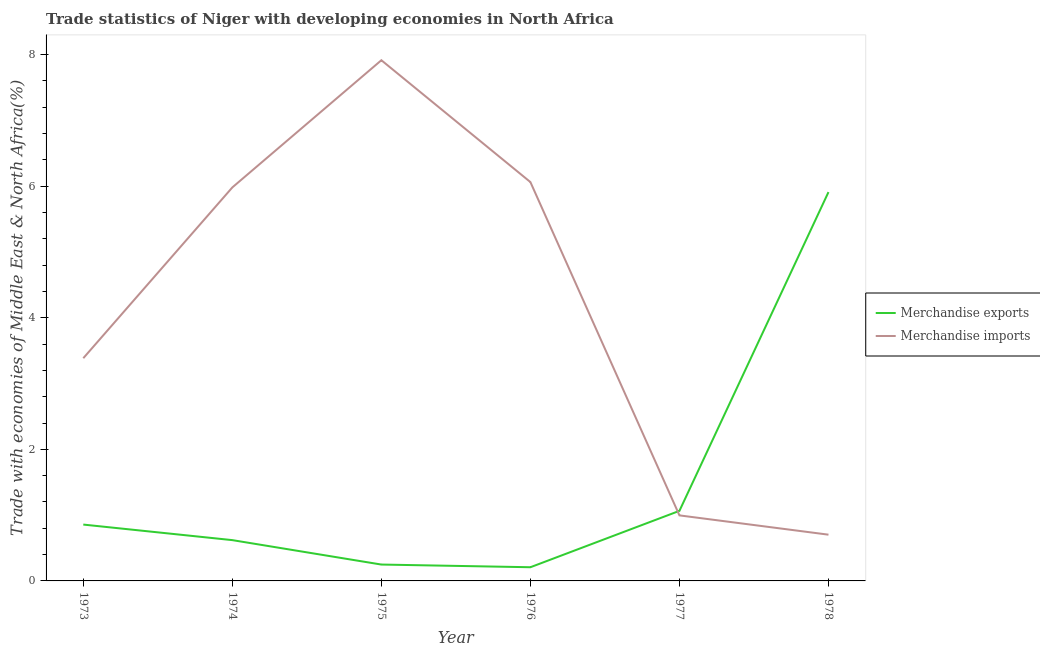Does the line corresponding to merchandise imports intersect with the line corresponding to merchandise exports?
Give a very brief answer. Yes. Is the number of lines equal to the number of legend labels?
Ensure brevity in your answer.  Yes. What is the merchandise imports in 1973?
Make the answer very short. 3.39. Across all years, what is the maximum merchandise exports?
Make the answer very short. 5.91. Across all years, what is the minimum merchandise imports?
Make the answer very short. 0.7. In which year was the merchandise exports maximum?
Provide a short and direct response. 1978. In which year was the merchandise imports minimum?
Give a very brief answer. 1978. What is the total merchandise exports in the graph?
Give a very brief answer. 8.91. What is the difference between the merchandise exports in 1977 and that in 1978?
Make the answer very short. -4.84. What is the difference between the merchandise exports in 1977 and the merchandise imports in 1978?
Give a very brief answer. 0.36. What is the average merchandise imports per year?
Your answer should be very brief. 4.17. In the year 1974, what is the difference between the merchandise imports and merchandise exports?
Offer a very short reply. 5.36. In how many years, is the merchandise exports greater than 1.6 %?
Your answer should be very brief. 1. What is the ratio of the merchandise exports in 1973 to that in 1977?
Offer a very short reply. 0.8. What is the difference between the highest and the second highest merchandise imports?
Give a very brief answer. 1.85. What is the difference between the highest and the lowest merchandise exports?
Your answer should be very brief. 5.7. Is the sum of the merchandise exports in 1974 and 1978 greater than the maximum merchandise imports across all years?
Provide a succinct answer. No. Does the merchandise exports monotonically increase over the years?
Keep it short and to the point. No. How many lines are there?
Your answer should be very brief. 2. How many years are there in the graph?
Your answer should be very brief. 6. Does the graph contain any zero values?
Offer a terse response. No. How are the legend labels stacked?
Give a very brief answer. Vertical. What is the title of the graph?
Your answer should be compact. Trade statistics of Niger with developing economies in North Africa. Does "Automatic Teller Machines" appear as one of the legend labels in the graph?
Provide a short and direct response. No. What is the label or title of the X-axis?
Offer a terse response. Year. What is the label or title of the Y-axis?
Your answer should be compact. Trade with economies of Middle East & North Africa(%). What is the Trade with economies of Middle East & North Africa(%) of Merchandise exports in 1973?
Provide a short and direct response. 0.86. What is the Trade with economies of Middle East & North Africa(%) of Merchandise imports in 1973?
Keep it short and to the point. 3.39. What is the Trade with economies of Middle East & North Africa(%) of Merchandise exports in 1974?
Make the answer very short. 0.62. What is the Trade with economies of Middle East & North Africa(%) of Merchandise imports in 1974?
Your answer should be compact. 5.98. What is the Trade with economies of Middle East & North Africa(%) in Merchandise exports in 1975?
Make the answer very short. 0.25. What is the Trade with economies of Middle East & North Africa(%) in Merchandise imports in 1975?
Make the answer very short. 7.91. What is the Trade with economies of Middle East & North Africa(%) of Merchandise exports in 1976?
Keep it short and to the point. 0.21. What is the Trade with economies of Middle East & North Africa(%) of Merchandise imports in 1976?
Offer a very short reply. 6.06. What is the Trade with economies of Middle East & North Africa(%) of Merchandise exports in 1977?
Offer a very short reply. 1.07. What is the Trade with economies of Middle East & North Africa(%) of Merchandise imports in 1977?
Make the answer very short. 1. What is the Trade with economies of Middle East & North Africa(%) in Merchandise exports in 1978?
Offer a terse response. 5.91. What is the Trade with economies of Middle East & North Africa(%) of Merchandise imports in 1978?
Your answer should be compact. 0.7. Across all years, what is the maximum Trade with economies of Middle East & North Africa(%) of Merchandise exports?
Keep it short and to the point. 5.91. Across all years, what is the maximum Trade with economies of Middle East & North Africa(%) of Merchandise imports?
Your answer should be compact. 7.91. Across all years, what is the minimum Trade with economies of Middle East & North Africa(%) of Merchandise exports?
Offer a terse response. 0.21. Across all years, what is the minimum Trade with economies of Middle East & North Africa(%) of Merchandise imports?
Give a very brief answer. 0.7. What is the total Trade with economies of Middle East & North Africa(%) of Merchandise exports in the graph?
Give a very brief answer. 8.91. What is the total Trade with economies of Middle East & North Africa(%) in Merchandise imports in the graph?
Give a very brief answer. 25.04. What is the difference between the Trade with economies of Middle East & North Africa(%) of Merchandise exports in 1973 and that in 1974?
Your response must be concise. 0.24. What is the difference between the Trade with economies of Middle East & North Africa(%) of Merchandise imports in 1973 and that in 1974?
Make the answer very short. -2.6. What is the difference between the Trade with economies of Middle East & North Africa(%) in Merchandise exports in 1973 and that in 1975?
Provide a short and direct response. 0.61. What is the difference between the Trade with economies of Middle East & North Africa(%) of Merchandise imports in 1973 and that in 1975?
Offer a terse response. -4.53. What is the difference between the Trade with economies of Middle East & North Africa(%) in Merchandise exports in 1973 and that in 1976?
Your response must be concise. 0.65. What is the difference between the Trade with economies of Middle East & North Africa(%) in Merchandise imports in 1973 and that in 1976?
Your response must be concise. -2.68. What is the difference between the Trade with economies of Middle East & North Africa(%) of Merchandise exports in 1973 and that in 1977?
Provide a short and direct response. -0.21. What is the difference between the Trade with economies of Middle East & North Africa(%) in Merchandise imports in 1973 and that in 1977?
Provide a short and direct response. 2.39. What is the difference between the Trade with economies of Middle East & North Africa(%) in Merchandise exports in 1973 and that in 1978?
Your answer should be very brief. -5.05. What is the difference between the Trade with economies of Middle East & North Africa(%) in Merchandise imports in 1973 and that in 1978?
Make the answer very short. 2.68. What is the difference between the Trade with economies of Middle East & North Africa(%) in Merchandise exports in 1974 and that in 1975?
Offer a very short reply. 0.37. What is the difference between the Trade with economies of Middle East & North Africa(%) of Merchandise imports in 1974 and that in 1975?
Offer a very short reply. -1.93. What is the difference between the Trade with economies of Middle East & North Africa(%) of Merchandise exports in 1974 and that in 1976?
Your answer should be very brief. 0.41. What is the difference between the Trade with economies of Middle East & North Africa(%) of Merchandise imports in 1974 and that in 1976?
Ensure brevity in your answer.  -0.08. What is the difference between the Trade with economies of Middle East & North Africa(%) in Merchandise exports in 1974 and that in 1977?
Offer a terse response. -0.44. What is the difference between the Trade with economies of Middle East & North Africa(%) in Merchandise imports in 1974 and that in 1977?
Your answer should be compact. 4.98. What is the difference between the Trade with economies of Middle East & North Africa(%) of Merchandise exports in 1974 and that in 1978?
Your answer should be compact. -5.29. What is the difference between the Trade with economies of Middle East & North Africa(%) in Merchandise imports in 1974 and that in 1978?
Keep it short and to the point. 5.28. What is the difference between the Trade with economies of Middle East & North Africa(%) in Merchandise exports in 1975 and that in 1976?
Offer a very short reply. 0.04. What is the difference between the Trade with economies of Middle East & North Africa(%) of Merchandise imports in 1975 and that in 1976?
Your response must be concise. 1.85. What is the difference between the Trade with economies of Middle East & North Africa(%) in Merchandise exports in 1975 and that in 1977?
Offer a very short reply. -0.82. What is the difference between the Trade with economies of Middle East & North Africa(%) of Merchandise imports in 1975 and that in 1977?
Your answer should be very brief. 6.92. What is the difference between the Trade with economies of Middle East & North Africa(%) of Merchandise exports in 1975 and that in 1978?
Provide a short and direct response. -5.66. What is the difference between the Trade with economies of Middle East & North Africa(%) in Merchandise imports in 1975 and that in 1978?
Give a very brief answer. 7.21. What is the difference between the Trade with economies of Middle East & North Africa(%) of Merchandise exports in 1976 and that in 1977?
Ensure brevity in your answer.  -0.86. What is the difference between the Trade with economies of Middle East & North Africa(%) of Merchandise imports in 1976 and that in 1977?
Ensure brevity in your answer.  5.07. What is the difference between the Trade with economies of Middle East & North Africa(%) in Merchandise exports in 1976 and that in 1978?
Offer a very short reply. -5.7. What is the difference between the Trade with economies of Middle East & North Africa(%) in Merchandise imports in 1976 and that in 1978?
Make the answer very short. 5.36. What is the difference between the Trade with economies of Middle East & North Africa(%) in Merchandise exports in 1977 and that in 1978?
Give a very brief answer. -4.84. What is the difference between the Trade with economies of Middle East & North Africa(%) of Merchandise imports in 1977 and that in 1978?
Ensure brevity in your answer.  0.29. What is the difference between the Trade with economies of Middle East & North Africa(%) of Merchandise exports in 1973 and the Trade with economies of Middle East & North Africa(%) of Merchandise imports in 1974?
Offer a terse response. -5.12. What is the difference between the Trade with economies of Middle East & North Africa(%) in Merchandise exports in 1973 and the Trade with economies of Middle East & North Africa(%) in Merchandise imports in 1975?
Keep it short and to the point. -7.06. What is the difference between the Trade with economies of Middle East & North Africa(%) of Merchandise exports in 1973 and the Trade with economies of Middle East & North Africa(%) of Merchandise imports in 1976?
Keep it short and to the point. -5.21. What is the difference between the Trade with economies of Middle East & North Africa(%) in Merchandise exports in 1973 and the Trade with economies of Middle East & North Africa(%) in Merchandise imports in 1977?
Your answer should be very brief. -0.14. What is the difference between the Trade with economies of Middle East & North Africa(%) in Merchandise exports in 1973 and the Trade with economies of Middle East & North Africa(%) in Merchandise imports in 1978?
Provide a short and direct response. 0.15. What is the difference between the Trade with economies of Middle East & North Africa(%) in Merchandise exports in 1974 and the Trade with economies of Middle East & North Africa(%) in Merchandise imports in 1975?
Provide a short and direct response. -7.29. What is the difference between the Trade with economies of Middle East & North Africa(%) of Merchandise exports in 1974 and the Trade with economies of Middle East & North Africa(%) of Merchandise imports in 1976?
Offer a terse response. -5.44. What is the difference between the Trade with economies of Middle East & North Africa(%) in Merchandise exports in 1974 and the Trade with economies of Middle East & North Africa(%) in Merchandise imports in 1977?
Your response must be concise. -0.38. What is the difference between the Trade with economies of Middle East & North Africa(%) of Merchandise exports in 1974 and the Trade with economies of Middle East & North Africa(%) of Merchandise imports in 1978?
Make the answer very short. -0.08. What is the difference between the Trade with economies of Middle East & North Africa(%) in Merchandise exports in 1975 and the Trade with economies of Middle East & North Africa(%) in Merchandise imports in 1976?
Give a very brief answer. -5.81. What is the difference between the Trade with economies of Middle East & North Africa(%) of Merchandise exports in 1975 and the Trade with economies of Middle East & North Africa(%) of Merchandise imports in 1977?
Give a very brief answer. -0.75. What is the difference between the Trade with economies of Middle East & North Africa(%) in Merchandise exports in 1975 and the Trade with economies of Middle East & North Africa(%) in Merchandise imports in 1978?
Provide a succinct answer. -0.45. What is the difference between the Trade with economies of Middle East & North Africa(%) of Merchandise exports in 1976 and the Trade with economies of Middle East & North Africa(%) of Merchandise imports in 1977?
Your answer should be very brief. -0.79. What is the difference between the Trade with economies of Middle East & North Africa(%) of Merchandise exports in 1976 and the Trade with economies of Middle East & North Africa(%) of Merchandise imports in 1978?
Make the answer very short. -0.49. What is the difference between the Trade with economies of Middle East & North Africa(%) of Merchandise exports in 1977 and the Trade with economies of Middle East & North Africa(%) of Merchandise imports in 1978?
Provide a succinct answer. 0.36. What is the average Trade with economies of Middle East & North Africa(%) of Merchandise exports per year?
Offer a very short reply. 1.48. What is the average Trade with economies of Middle East & North Africa(%) in Merchandise imports per year?
Offer a very short reply. 4.17. In the year 1973, what is the difference between the Trade with economies of Middle East & North Africa(%) in Merchandise exports and Trade with economies of Middle East & North Africa(%) in Merchandise imports?
Keep it short and to the point. -2.53. In the year 1974, what is the difference between the Trade with economies of Middle East & North Africa(%) of Merchandise exports and Trade with economies of Middle East & North Africa(%) of Merchandise imports?
Keep it short and to the point. -5.36. In the year 1975, what is the difference between the Trade with economies of Middle East & North Africa(%) in Merchandise exports and Trade with economies of Middle East & North Africa(%) in Merchandise imports?
Provide a succinct answer. -7.67. In the year 1976, what is the difference between the Trade with economies of Middle East & North Africa(%) of Merchandise exports and Trade with economies of Middle East & North Africa(%) of Merchandise imports?
Give a very brief answer. -5.85. In the year 1977, what is the difference between the Trade with economies of Middle East & North Africa(%) in Merchandise exports and Trade with economies of Middle East & North Africa(%) in Merchandise imports?
Offer a very short reply. 0.07. In the year 1978, what is the difference between the Trade with economies of Middle East & North Africa(%) of Merchandise exports and Trade with economies of Middle East & North Africa(%) of Merchandise imports?
Keep it short and to the point. 5.21. What is the ratio of the Trade with economies of Middle East & North Africa(%) in Merchandise exports in 1973 to that in 1974?
Offer a terse response. 1.38. What is the ratio of the Trade with economies of Middle East & North Africa(%) in Merchandise imports in 1973 to that in 1974?
Make the answer very short. 0.57. What is the ratio of the Trade with economies of Middle East & North Africa(%) of Merchandise exports in 1973 to that in 1975?
Your response must be concise. 3.44. What is the ratio of the Trade with economies of Middle East & North Africa(%) in Merchandise imports in 1973 to that in 1975?
Keep it short and to the point. 0.43. What is the ratio of the Trade with economies of Middle East & North Africa(%) in Merchandise exports in 1973 to that in 1976?
Your response must be concise. 4.12. What is the ratio of the Trade with economies of Middle East & North Africa(%) of Merchandise imports in 1973 to that in 1976?
Your response must be concise. 0.56. What is the ratio of the Trade with economies of Middle East & North Africa(%) in Merchandise exports in 1973 to that in 1977?
Ensure brevity in your answer.  0.8. What is the ratio of the Trade with economies of Middle East & North Africa(%) of Merchandise imports in 1973 to that in 1977?
Give a very brief answer. 3.4. What is the ratio of the Trade with economies of Middle East & North Africa(%) in Merchandise exports in 1973 to that in 1978?
Ensure brevity in your answer.  0.14. What is the ratio of the Trade with economies of Middle East & North Africa(%) in Merchandise imports in 1973 to that in 1978?
Make the answer very short. 4.82. What is the ratio of the Trade with economies of Middle East & North Africa(%) in Merchandise exports in 1974 to that in 1975?
Keep it short and to the point. 2.49. What is the ratio of the Trade with economies of Middle East & North Africa(%) in Merchandise imports in 1974 to that in 1975?
Provide a succinct answer. 0.76. What is the ratio of the Trade with economies of Middle East & North Africa(%) in Merchandise exports in 1974 to that in 1976?
Your response must be concise. 2.98. What is the ratio of the Trade with economies of Middle East & North Africa(%) of Merchandise imports in 1974 to that in 1976?
Offer a terse response. 0.99. What is the ratio of the Trade with economies of Middle East & North Africa(%) of Merchandise exports in 1974 to that in 1977?
Provide a short and direct response. 0.58. What is the ratio of the Trade with economies of Middle East & North Africa(%) in Merchandise imports in 1974 to that in 1977?
Give a very brief answer. 6. What is the ratio of the Trade with economies of Middle East & North Africa(%) in Merchandise exports in 1974 to that in 1978?
Give a very brief answer. 0.1. What is the ratio of the Trade with economies of Middle East & North Africa(%) of Merchandise imports in 1974 to that in 1978?
Your answer should be very brief. 8.51. What is the ratio of the Trade with economies of Middle East & North Africa(%) in Merchandise exports in 1975 to that in 1976?
Your response must be concise. 1.2. What is the ratio of the Trade with economies of Middle East & North Africa(%) in Merchandise imports in 1975 to that in 1976?
Give a very brief answer. 1.31. What is the ratio of the Trade with economies of Middle East & North Africa(%) of Merchandise exports in 1975 to that in 1977?
Your answer should be very brief. 0.23. What is the ratio of the Trade with economies of Middle East & North Africa(%) in Merchandise imports in 1975 to that in 1977?
Your answer should be very brief. 7.95. What is the ratio of the Trade with economies of Middle East & North Africa(%) in Merchandise exports in 1975 to that in 1978?
Make the answer very short. 0.04. What is the ratio of the Trade with economies of Middle East & North Africa(%) in Merchandise imports in 1975 to that in 1978?
Offer a very short reply. 11.26. What is the ratio of the Trade with economies of Middle East & North Africa(%) of Merchandise exports in 1976 to that in 1977?
Offer a terse response. 0.2. What is the ratio of the Trade with economies of Middle East & North Africa(%) in Merchandise imports in 1976 to that in 1977?
Ensure brevity in your answer.  6.09. What is the ratio of the Trade with economies of Middle East & North Africa(%) of Merchandise exports in 1976 to that in 1978?
Your response must be concise. 0.04. What is the ratio of the Trade with economies of Middle East & North Africa(%) in Merchandise imports in 1976 to that in 1978?
Provide a succinct answer. 8.62. What is the ratio of the Trade with economies of Middle East & North Africa(%) of Merchandise exports in 1977 to that in 1978?
Your answer should be compact. 0.18. What is the ratio of the Trade with economies of Middle East & North Africa(%) of Merchandise imports in 1977 to that in 1978?
Ensure brevity in your answer.  1.42. What is the difference between the highest and the second highest Trade with economies of Middle East & North Africa(%) in Merchandise exports?
Give a very brief answer. 4.84. What is the difference between the highest and the second highest Trade with economies of Middle East & North Africa(%) in Merchandise imports?
Give a very brief answer. 1.85. What is the difference between the highest and the lowest Trade with economies of Middle East & North Africa(%) in Merchandise exports?
Make the answer very short. 5.7. What is the difference between the highest and the lowest Trade with economies of Middle East & North Africa(%) in Merchandise imports?
Provide a succinct answer. 7.21. 